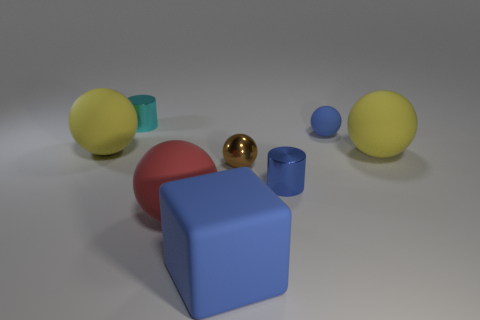What number of blue objects are tiny matte things or big rubber blocks?
Provide a succinct answer. 2. What is the small blue thing that is in front of the tiny brown metal object made of?
Keep it short and to the point. Metal. There is a yellow thing that is on the left side of the cyan metallic cylinder; how many cylinders are behind it?
Offer a very short reply. 1. What number of tiny rubber objects have the same shape as the large red object?
Make the answer very short. 1. What number of large blue matte blocks are there?
Offer a very short reply. 1. There is a large matte block that is right of the cyan cylinder; what color is it?
Offer a terse response. Blue. What color is the ball left of the big red matte object in front of the small rubber object?
Provide a succinct answer. Yellow. There is another ball that is the same size as the blue matte sphere; what is its color?
Provide a succinct answer. Brown. How many matte objects are to the right of the small blue rubber thing and left of the small rubber sphere?
Keep it short and to the point. 0. There is a matte object that is the same color as the rubber cube; what shape is it?
Keep it short and to the point. Sphere. 